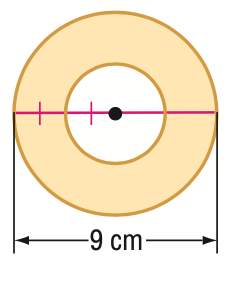Answer the mathemtical geometry problem and directly provide the correct option letter.
Question: Find the area of the shaded region.
Choices: A: 14.1 B: 15.9 C: 47.7 D: 63.6 C 